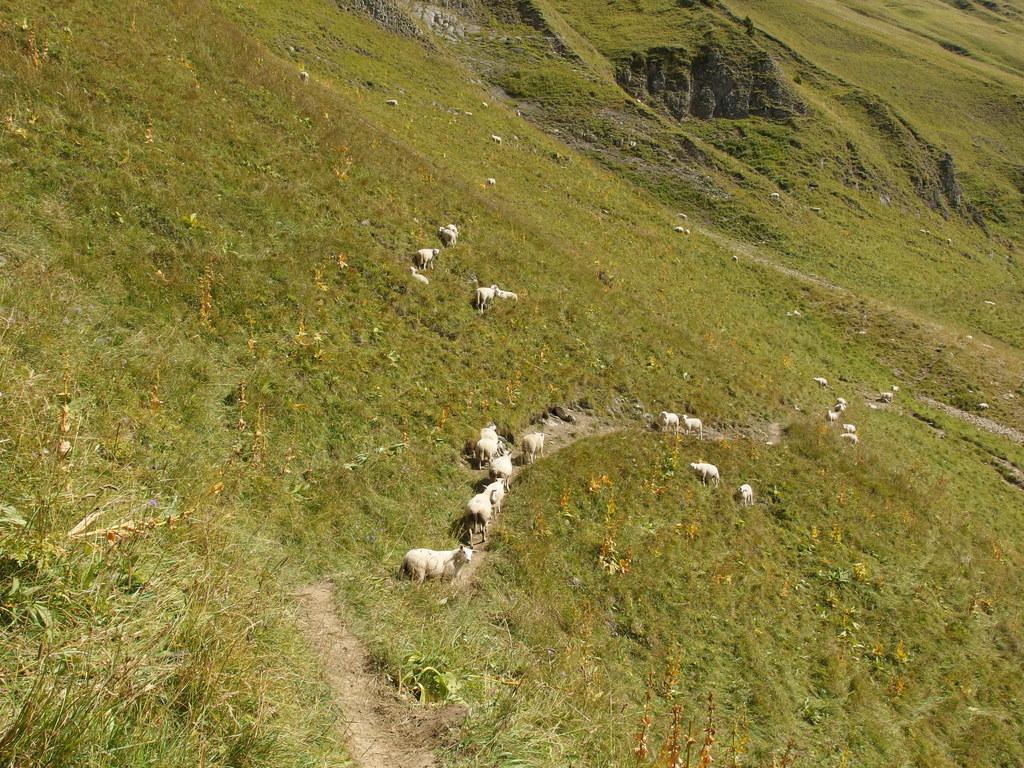Please provide a concise description of this image. In this image, we can see plants, grass, walkway and animals. 